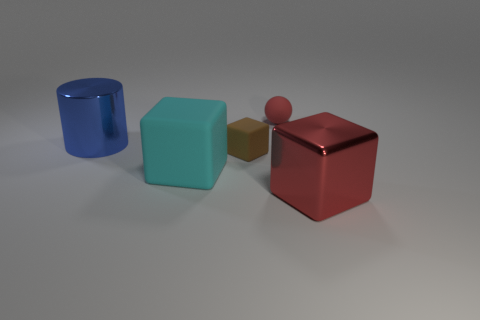There is a small cube that is the same material as the tiny red object; what color is it?
Your answer should be compact. Brown. What number of big blue objects have the same material as the small block?
Give a very brief answer. 0. There is a red object that is behind the red block; does it have the same size as the red thing that is in front of the tiny red matte thing?
Your answer should be compact. No. What is the tiny brown cube in front of the small object on the right side of the tiny brown cube made of?
Make the answer very short. Rubber. Is the number of blue metal things on the right side of the red rubber ball less than the number of small matte objects that are to the left of the large blue metal cylinder?
Offer a very short reply. No. What material is the small ball that is the same color as the large metal block?
Your answer should be compact. Rubber. Is there any other thing that is the same shape as the blue shiny object?
Your response must be concise. No. What material is the red object on the left side of the red metal thing?
Give a very brief answer. Rubber. Are there any cyan rubber blocks on the right side of the tiny red sphere?
Your answer should be very brief. No. What is the shape of the blue object?
Your answer should be very brief. Cylinder. 